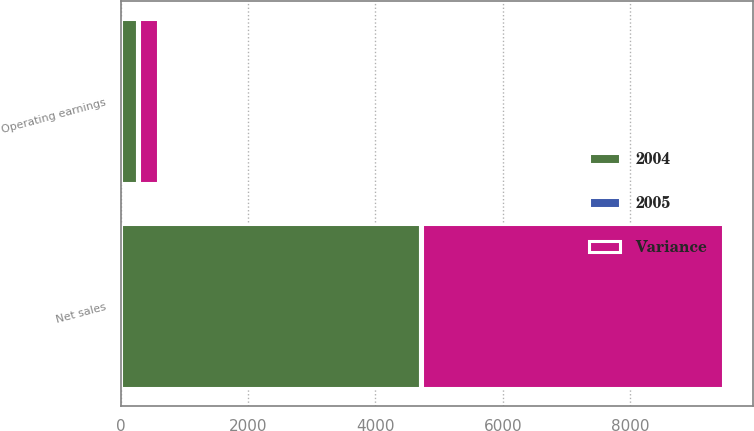<chart> <loc_0><loc_0><loc_500><loc_500><stacked_bar_chart><ecel><fcel>Net sales<fcel>Operating earnings<nl><fcel>2004<fcel>4695<fcel>249<nl><fcel>Variance<fcel>4726<fcel>292<nl><fcel>2005<fcel>31<fcel>43<nl></chart> 